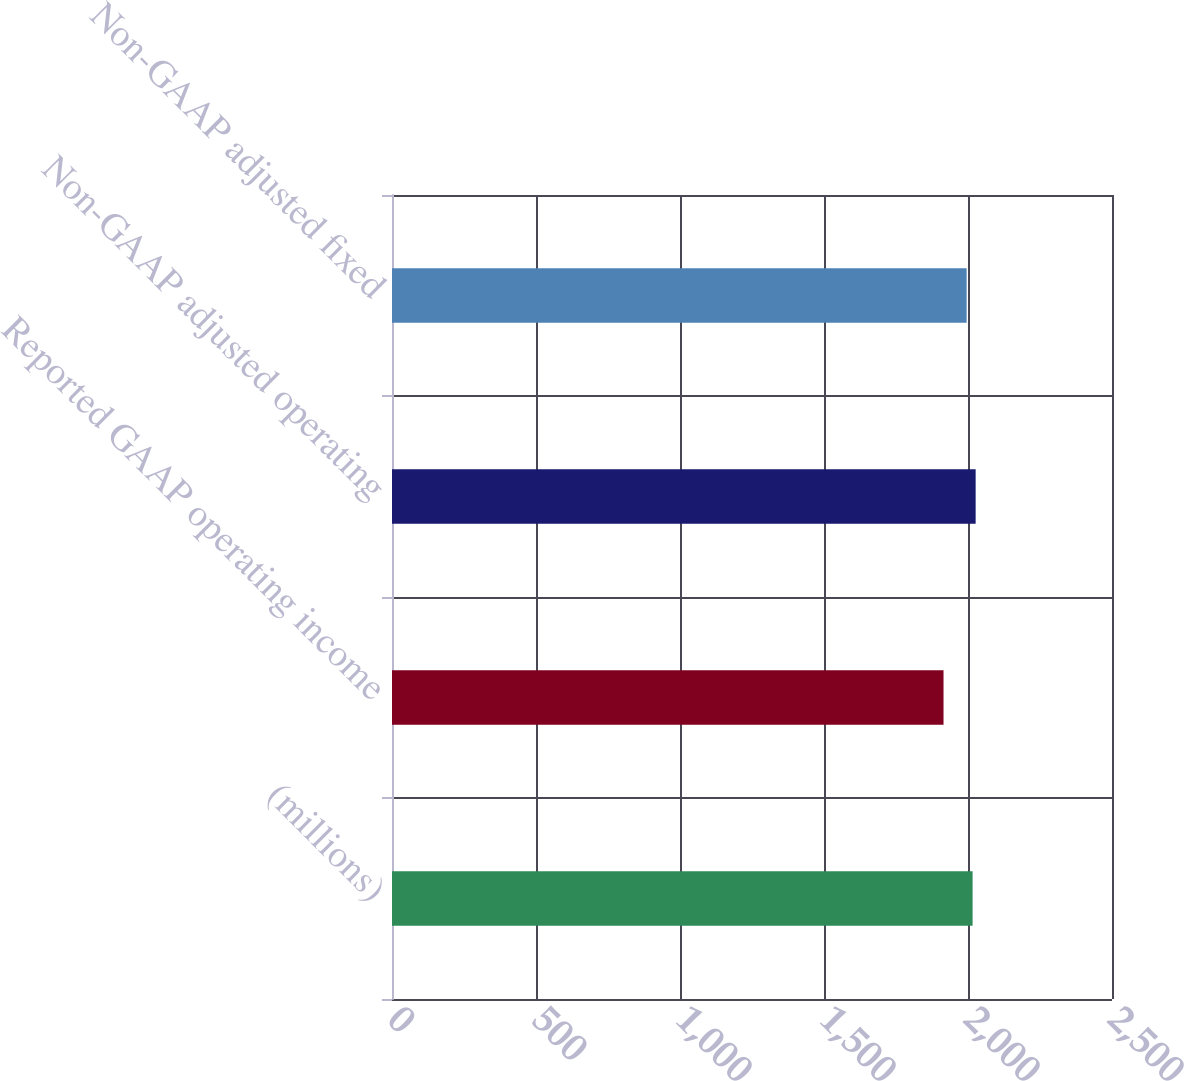<chart> <loc_0><loc_0><loc_500><loc_500><bar_chart><fcel>(millions)<fcel>Reported GAAP operating income<fcel>Non-GAAP adjusted operating<fcel>Non-GAAP adjusted fixed<nl><fcel>2016<fcel>1915<fcel>2026.55<fcel>1995.3<nl></chart> 